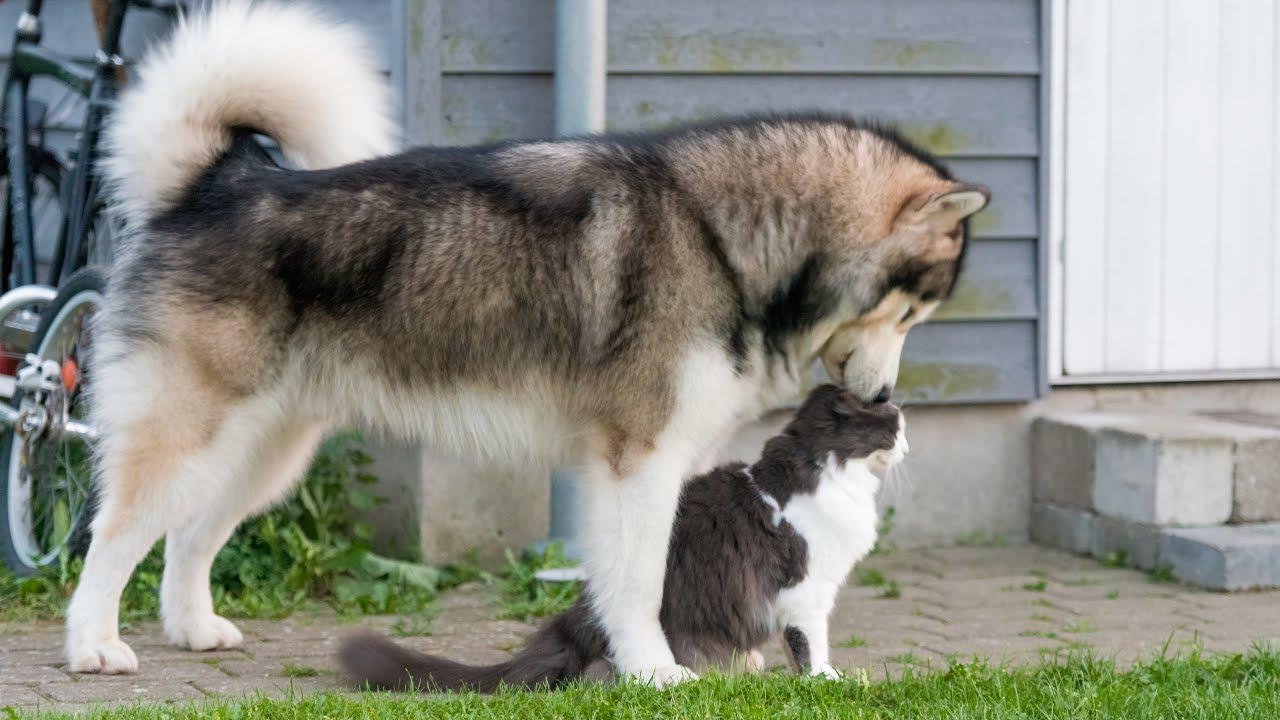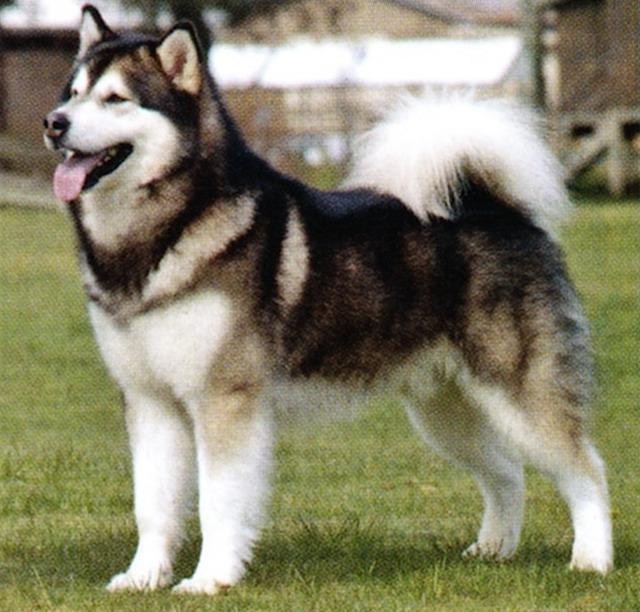The first image is the image on the left, the second image is the image on the right. Analyze the images presented: Is the assertion "There is at least one person visible behind a dog." valid? Answer yes or no. No. 